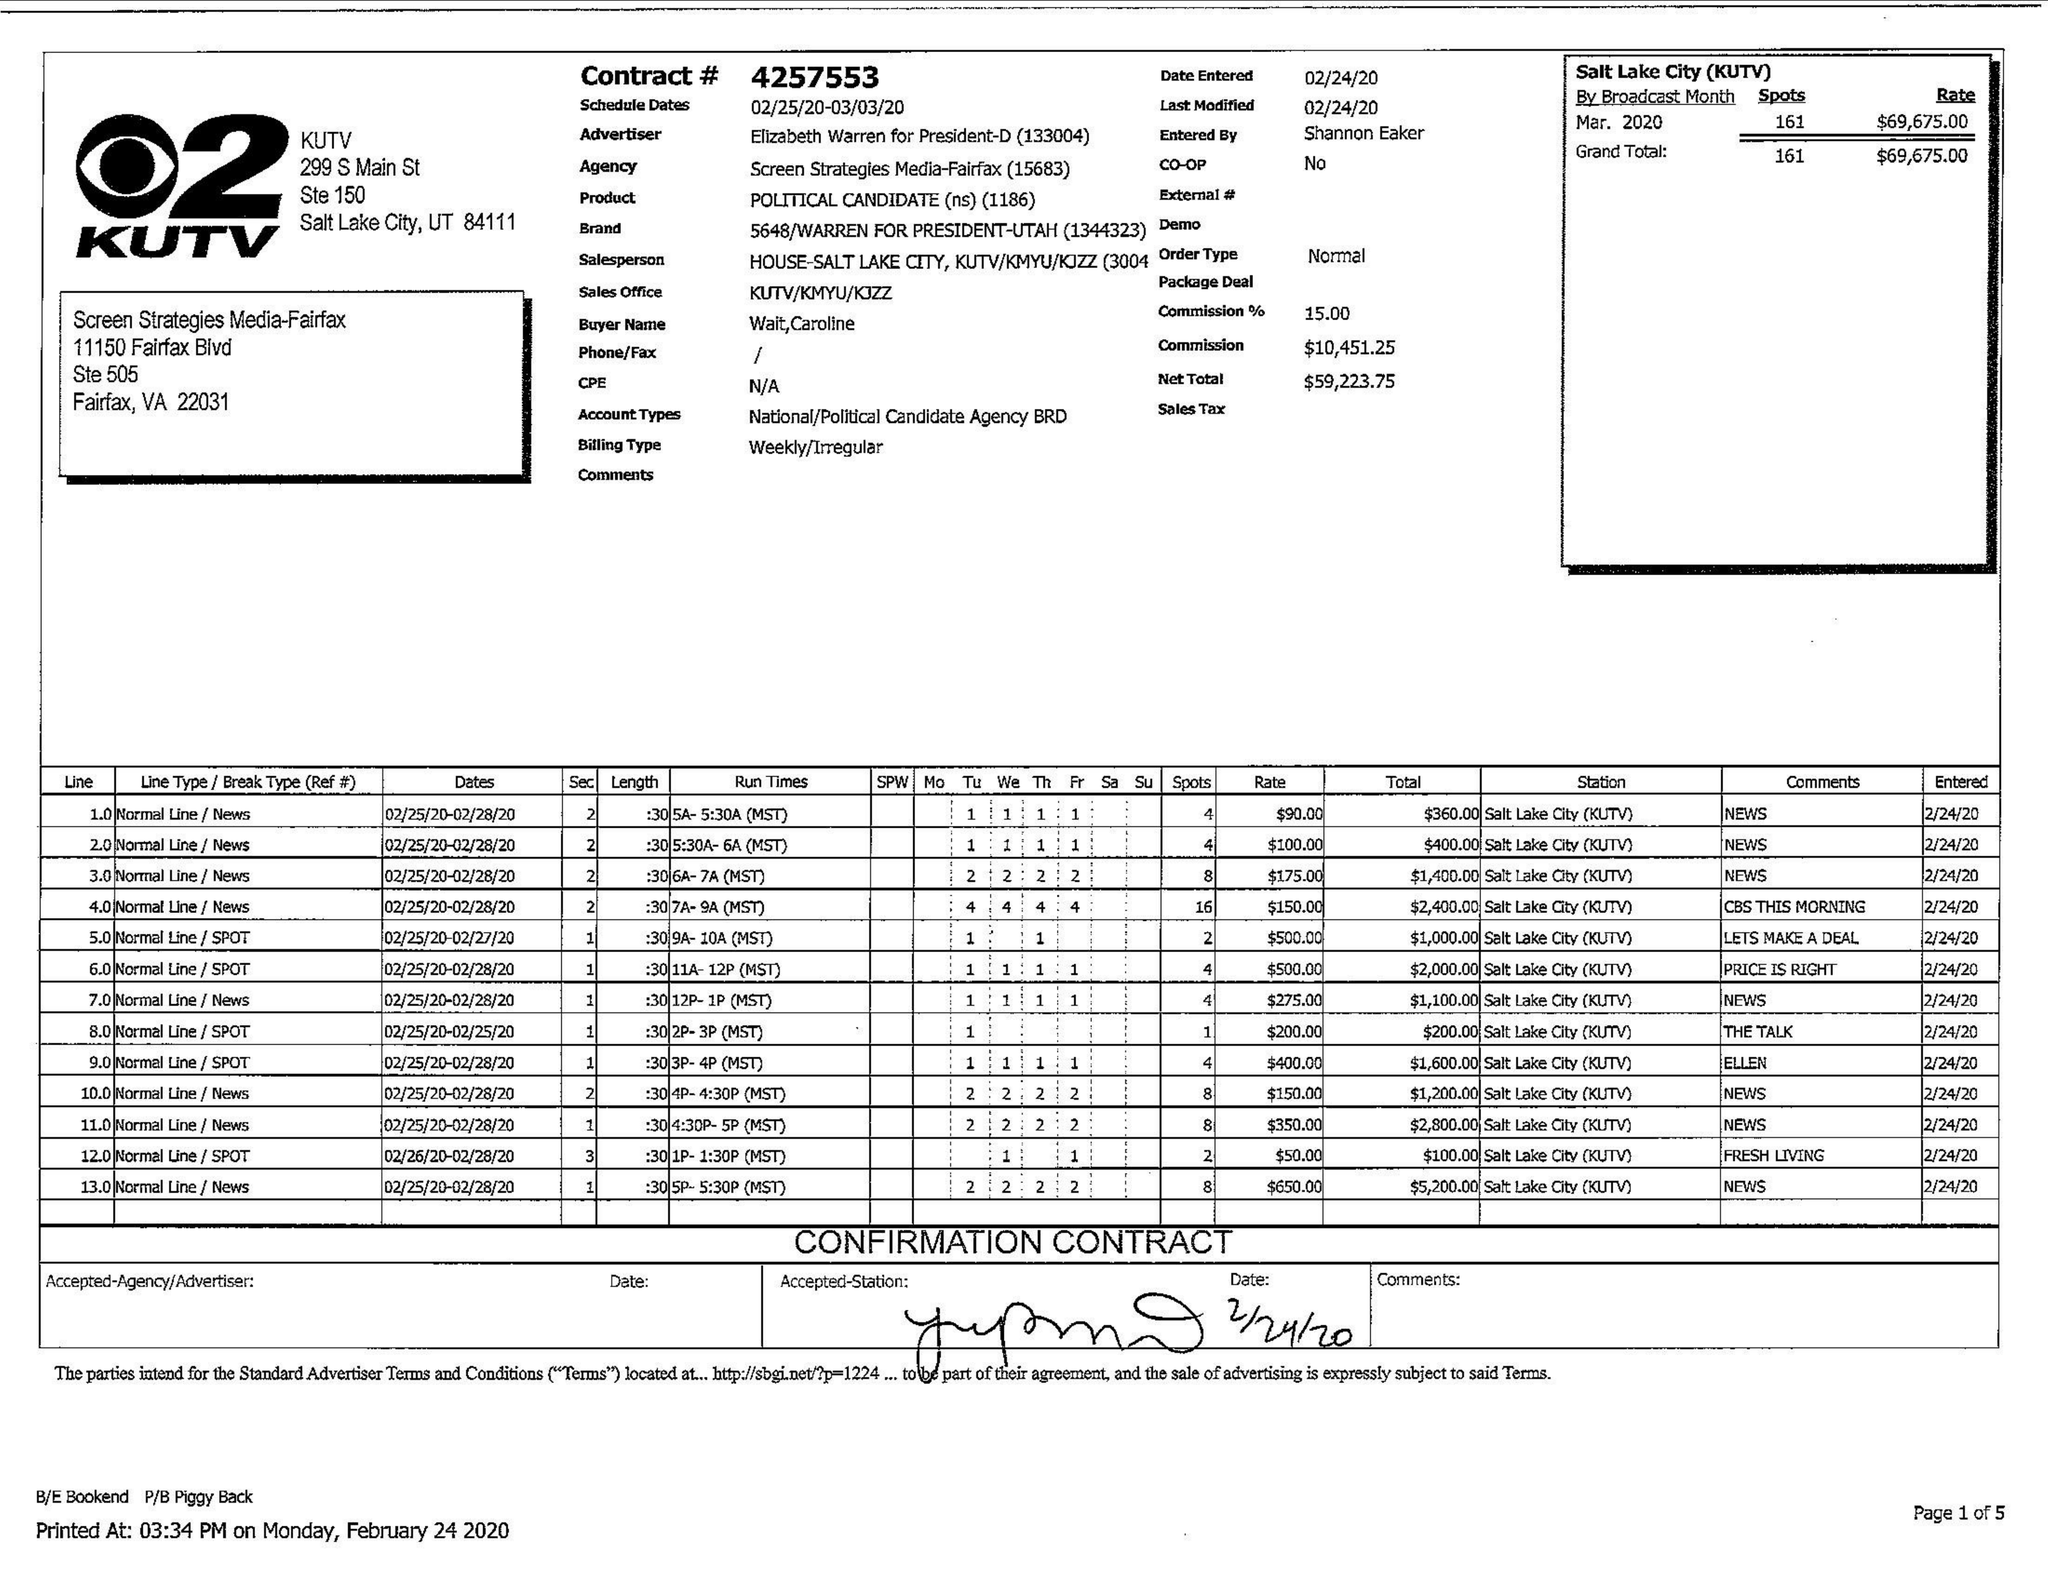What is the value for the flight_to?
Answer the question using a single word or phrase. 03/03/20 